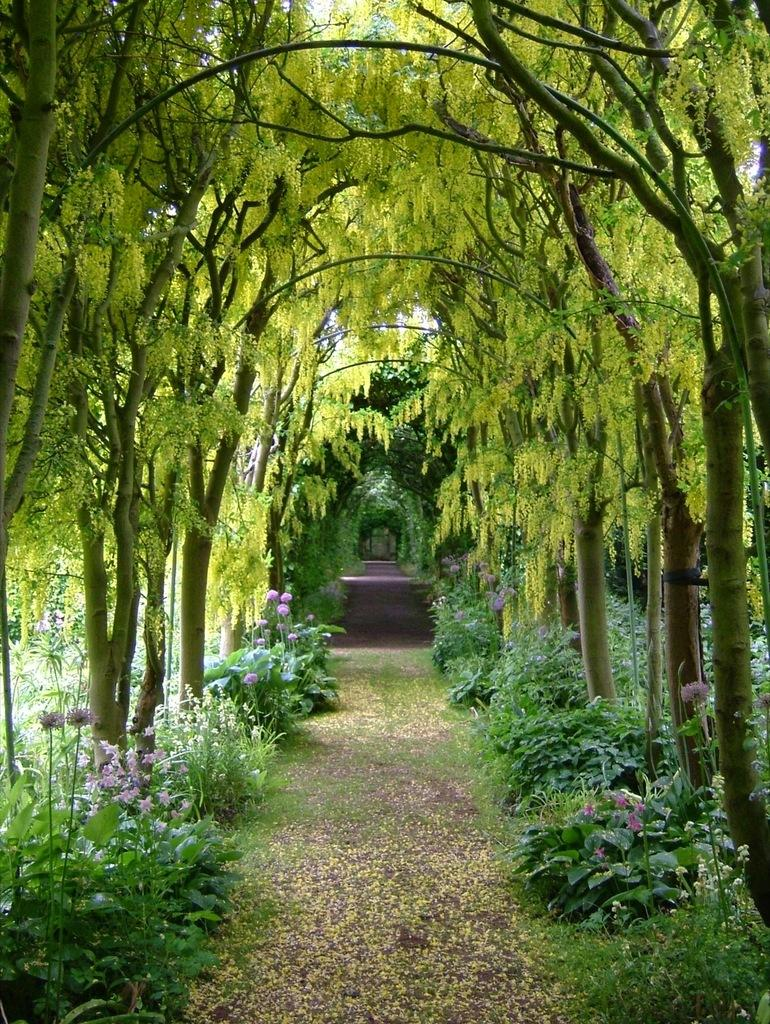What can be seen in the foreground of the image? There is a path in the foreground of the image. What is located on either side of the path? Plants and trees are present on either side of the path. Who is the owner of the pipe seen in the image? There is no pipe present in the image. Can you tell me how many yaks are grazing on the plants in the image? There are no yaks present in the image; only plants and trees are visible on either side of the path. 